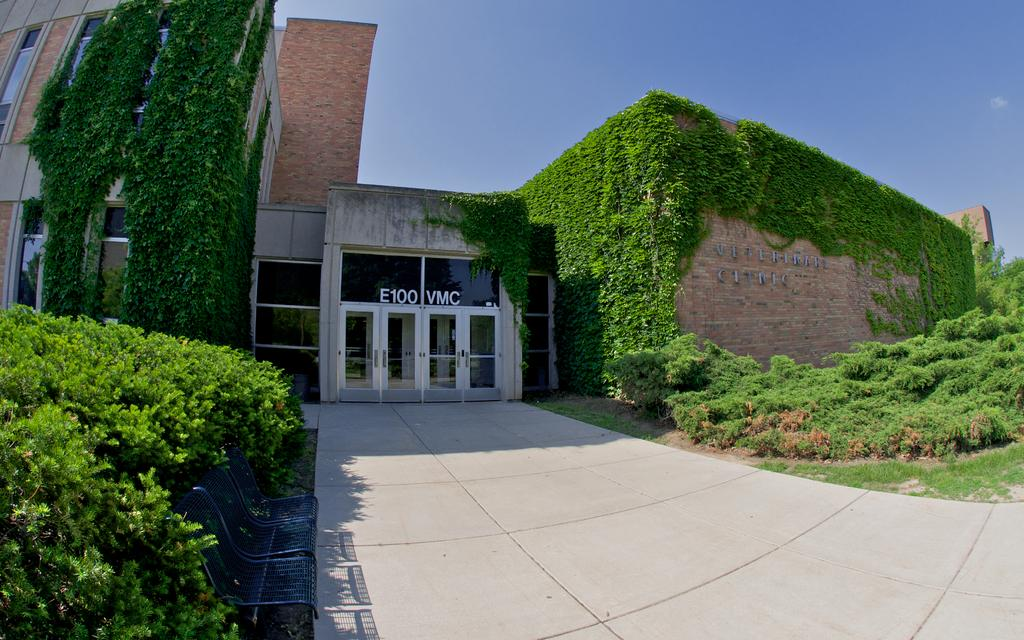What type of pathway is visible in the image? There is a walkway in the image. What can be seen on the left side of the image? There are trees on the left side of the image. What is present on the right side of the image? There are plants on the right side of the image. What is visible in the background of the image? There is a building and the clear sky in the background of the image. What type of coal is being used to power the lift in the image? There is no coal or lift present in the image. What is the quill used for in the image? There is no quill present in the image. 